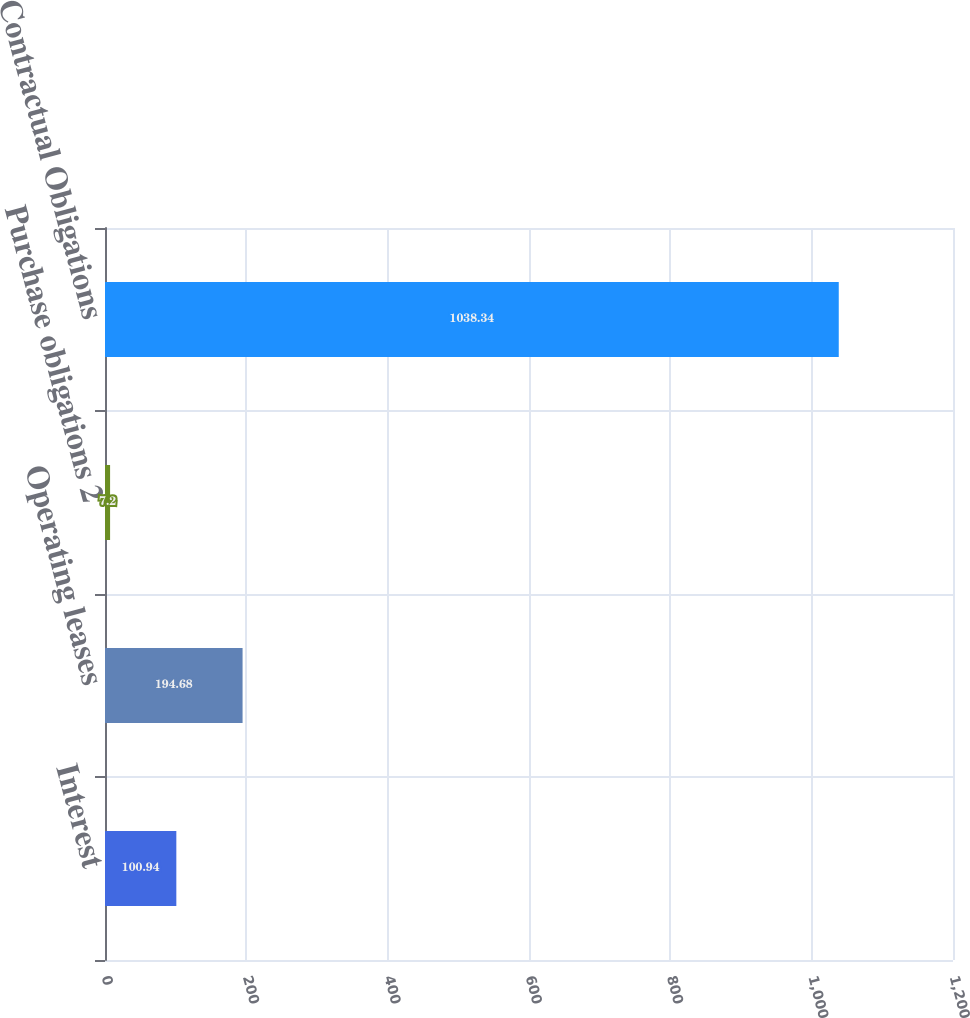Convert chart. <chart><loc_0><loc_0><loc_500><loc_500><bar_chart><fcel>Interest<fcel>Operating leases<fcel>Purchase obligations 2<fcel>Total Contractual Obligations<nl><fcel>100.94<fcel>194.68<fcel>7.2<fcel>1038.34<nl></chart> 